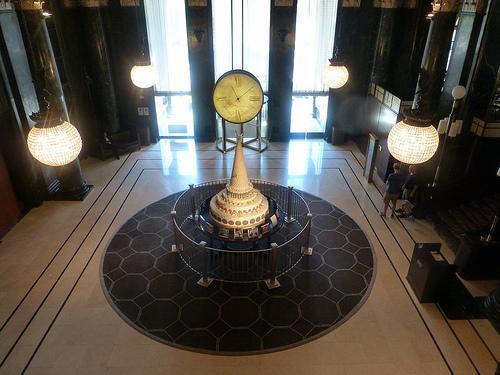How many clocks are there?
Give a very brief answer. 1. 